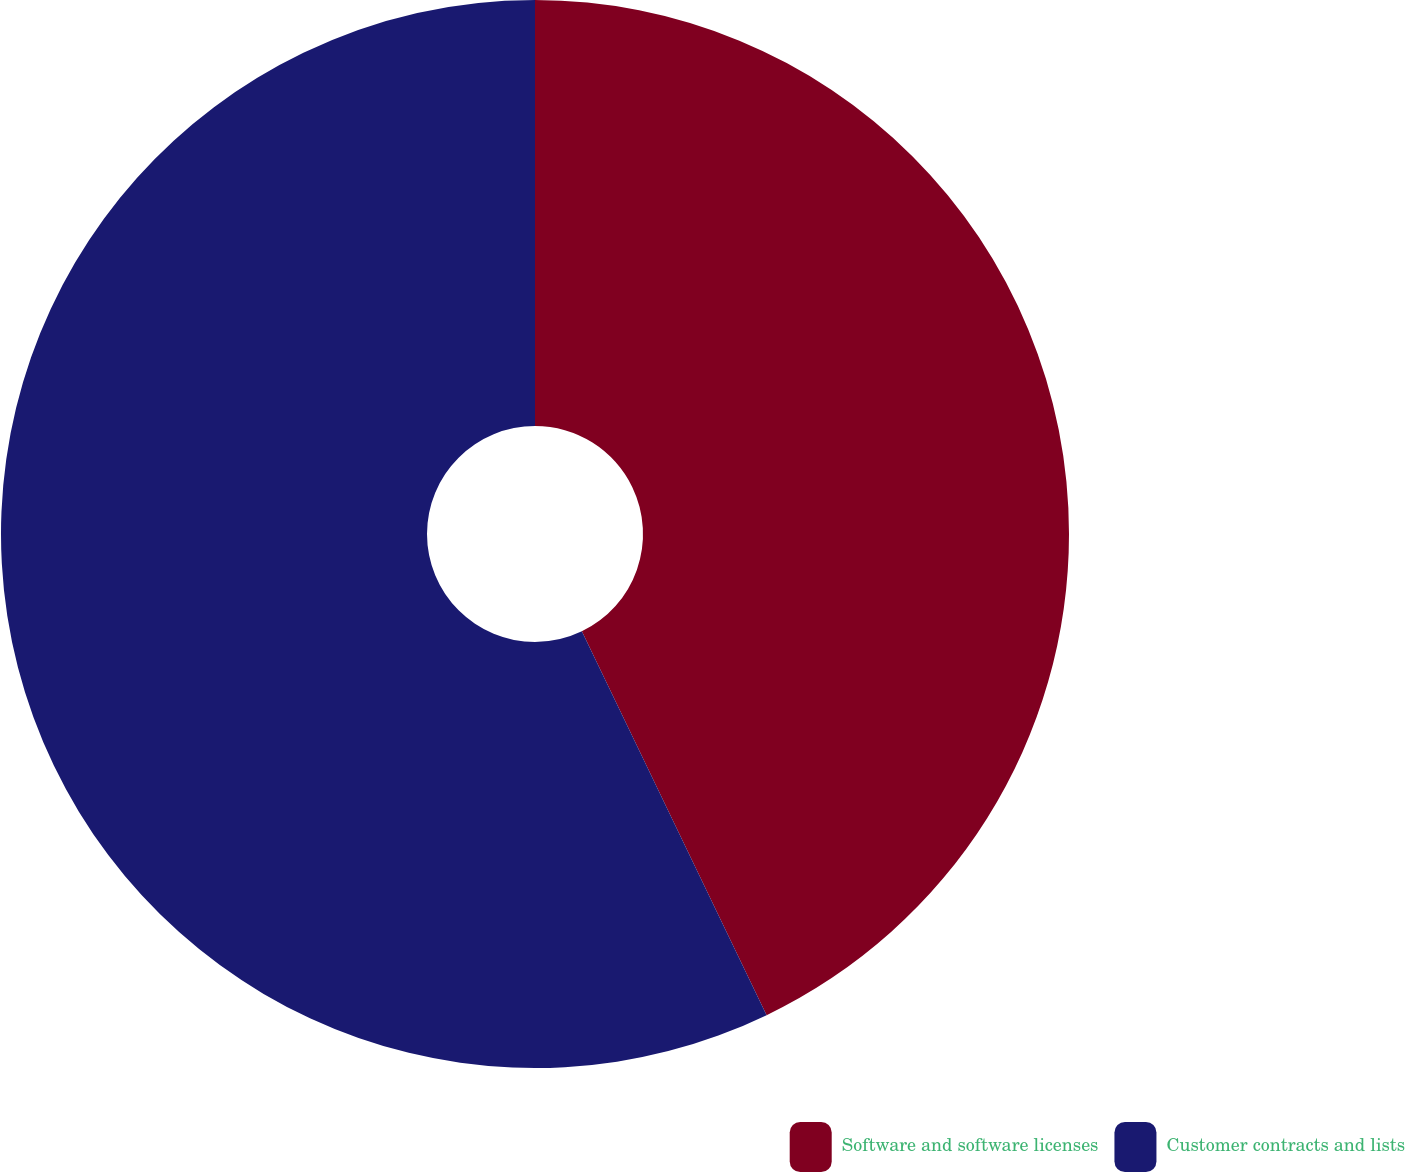<chart> <loc_0><loc_0><loc_500><loc_500><pie_chart><fcel>Software and software licenses<fcel>Customer contracts and lists<nl><fcel>42.86%<fcel>57.14%<nl></chart> 